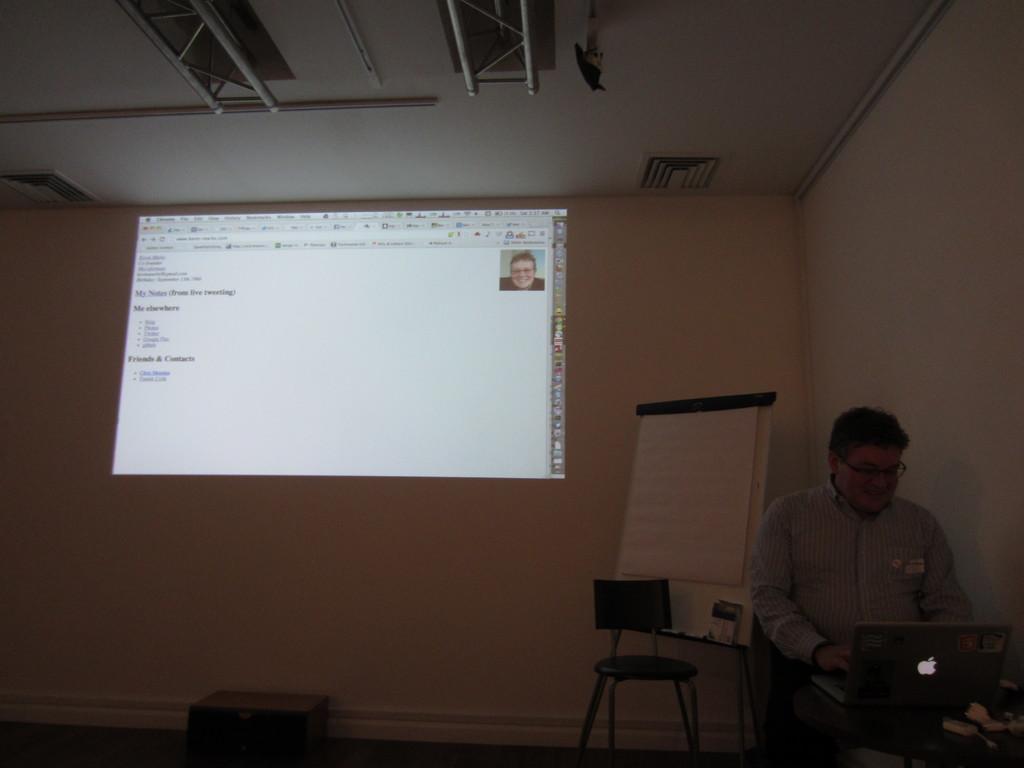Describe this image in one or two sentences. On the left there is a man who is standing at the table and he is working on the laptop. In the back we can see projector screen. Here we can see board near to the chair. On the top we can see steel rods. 